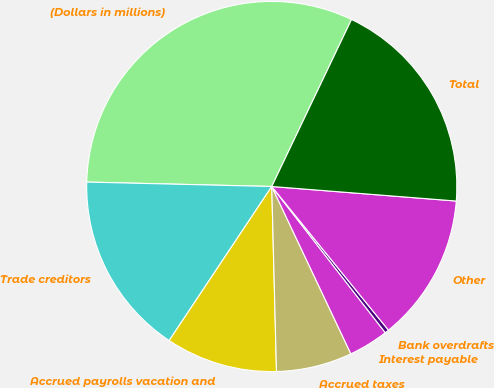Convert chart to OTSL. <chart><loc_0><loc_0><loc_500><loc_500><pie_chart><fcel>(Dollars in millions)<fcel>Trade creditors<fcel>Accrued payrolls vacation and<fcel>Accrued taxes<fcel>Interest payable<fcel>Bank overdrafts<fcel>Other<fcel>Total<nl><fcel>31.71%<fcel>16.03%<fcel>9.76%<fcel>6.62%<fcel>3.48%<fcel>0.35%<fcel>12.89%<fcel>19.16%<nl></chart> 